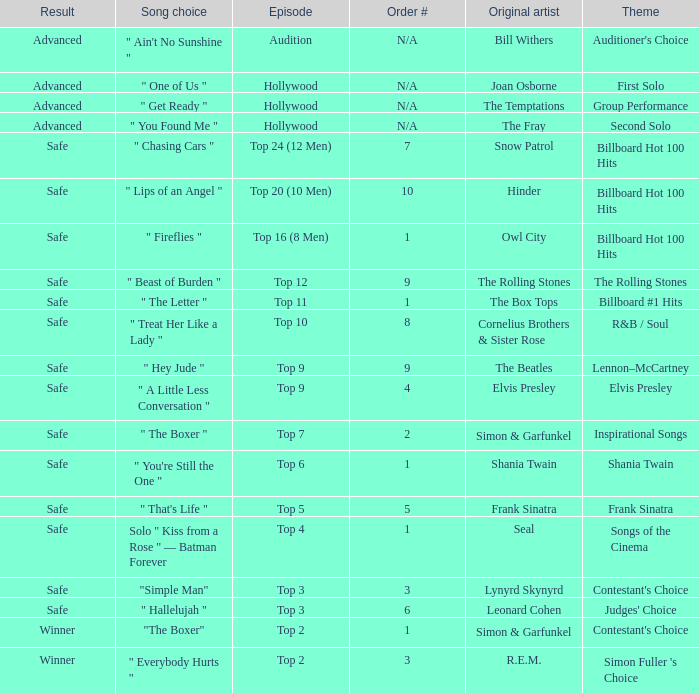The original artist Joan Osborne has what result? Advanced. 